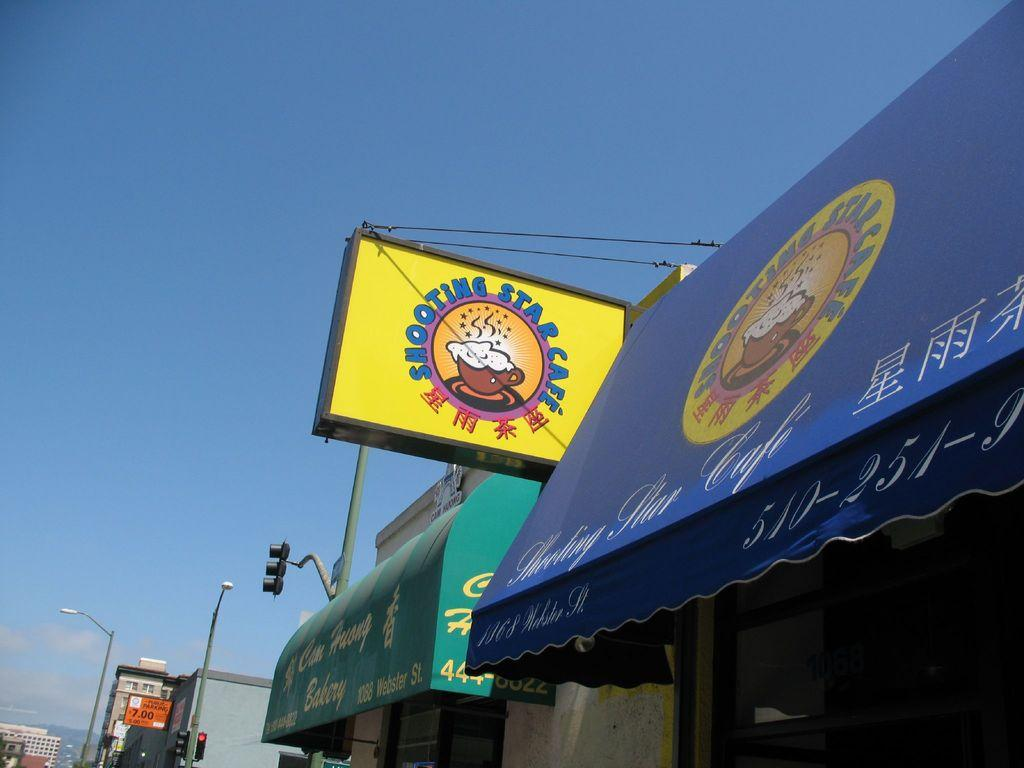<image>
Create a compact narrative representing the image presented. The Shooting Star Cafe has a blue awning outside. 